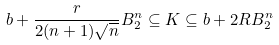<formula> <loc_0><loc_0><loc_500><loc_500>b + \frac { r } { 2 ( n + 1 ) \sqrt { n } } B _ { 2 } ^ { n } \subseteq K \subseteq b + 2 R B _ { 2 } ^ { n }</formula> 